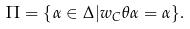<formula> <loc_0><loc_0><loc_500><loc_500>\Pi = \{ \alpha \in \Delta | w _ { C } \theta \alpha = \alpha \} .</formula> 